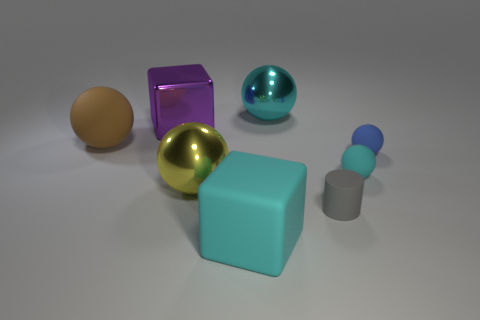There is another big rubber thing that is the same shape as the big yellow object; what is its color?
Your answer should be compact. Brown. Are there the same number of big purple metal blocks that are behind the tiny gray matte object and small gray rubber cylinders?
Keep it short and to the point. Yes. What number of spheres are either big purple metal objects or big things?
Keep it short and to the point. 3. There is a cylinder that is made of the same material as the large cyan block; what color is it?
Give a very brief answer. Gray. Does the yellow sphere have the same material as the cyan object behind the large metallic cube?
Keep it short and to the point. Yes. How many objects are tiny cyan matte balls or rubber cylinders?
Your answer should be compact. 2. What is the material of the tiny ball that is the same color as the large rubber block?
Ensure brevity in your answer.  Rubber. Is there a cyan metal thing of the same shape as the big brown matte object?
Your answer should be compact. Yes. What number of large cyan matte things are behind the cyan matte ball?
Make the answer very short. 0. What is the material of the big brown object on the left side of the metal thing in front of the big brown ball?
Offer a very short reply. Rubber. 